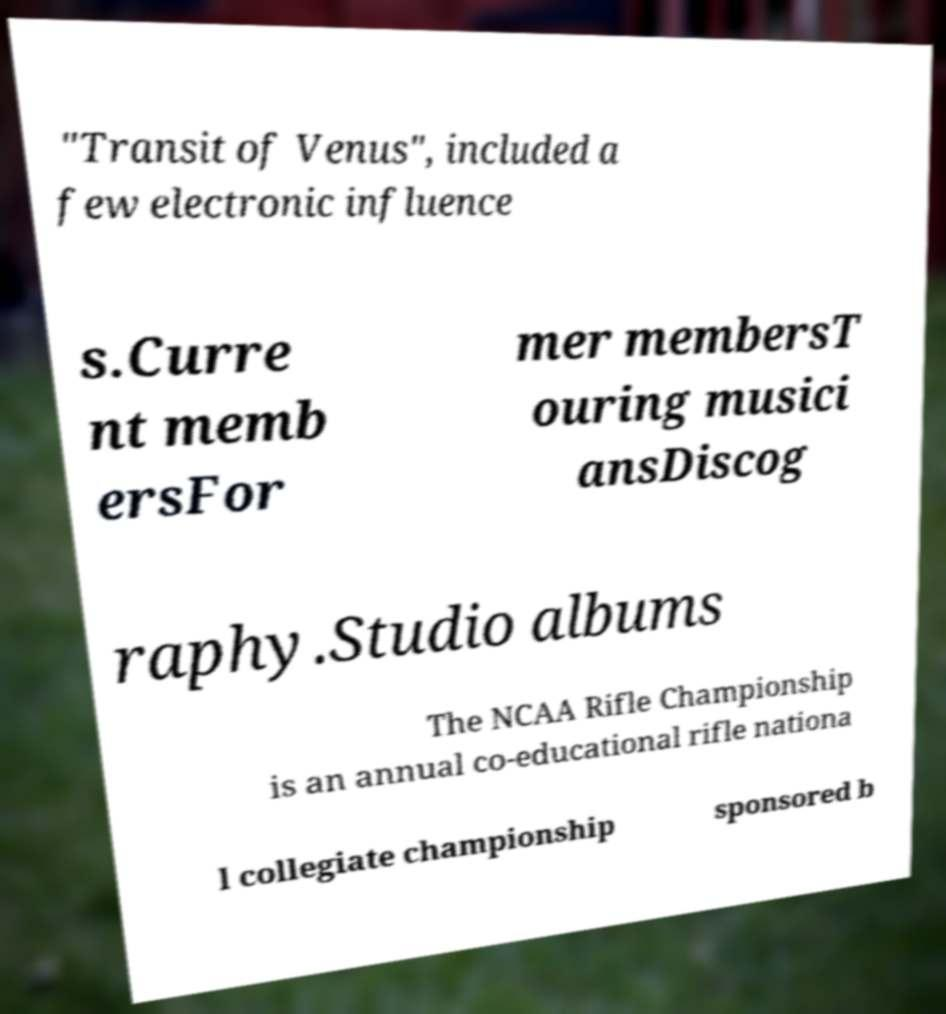Could you assist in decoding the text presented in this image and type it out clearly? "Transit of Venus", included a few electronic influence s.Curre nt memb ersFor mer membersT ouring musici ansDiscog raphy.Studio albums The NCAA Rifle Championship is an annual co-educational rifle nationa l collegiate championship sponsored b 